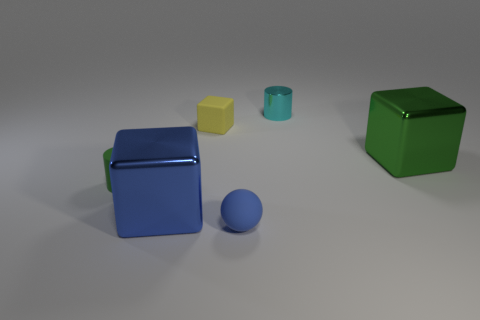Are there any cyan matte blocks that have the same size as the yellow block?
Keep it short and to the point. No. There is a small green thing; is its shape the same as the metallic thing behind the large green cube?
Make the answer very short. Yes. How many cubes are either small brown shiny things or tiny green rubber objects?
Ensure brevity in your answer.  0. What color is the matte sphere?
Give a very brief answer. Blue. Is the number of green metallic objects greater than the number of red cylinders?
Give a very brief answer. Yes. How many things are tiny things on the right side of the tiny blue rubber ball or green blocks?
Ensure brevity in your answer.  2. Does the big blue thing have the same material as the large green thing?
Keep it short and to the point. Yes. There is a green matte thing that is the same shape as the cyan object; what size is it?
Ensure brevity in your answer.  Small. Does the green object that is to the left of the small cyan cylinder have the same shape as the small object that is behind the small yellow object?
Make the answer very short. Yes. Do the green rubber cylinder and the matte object that is right of the matte cube have the same size?
Your answer should be very brief. Yes. 